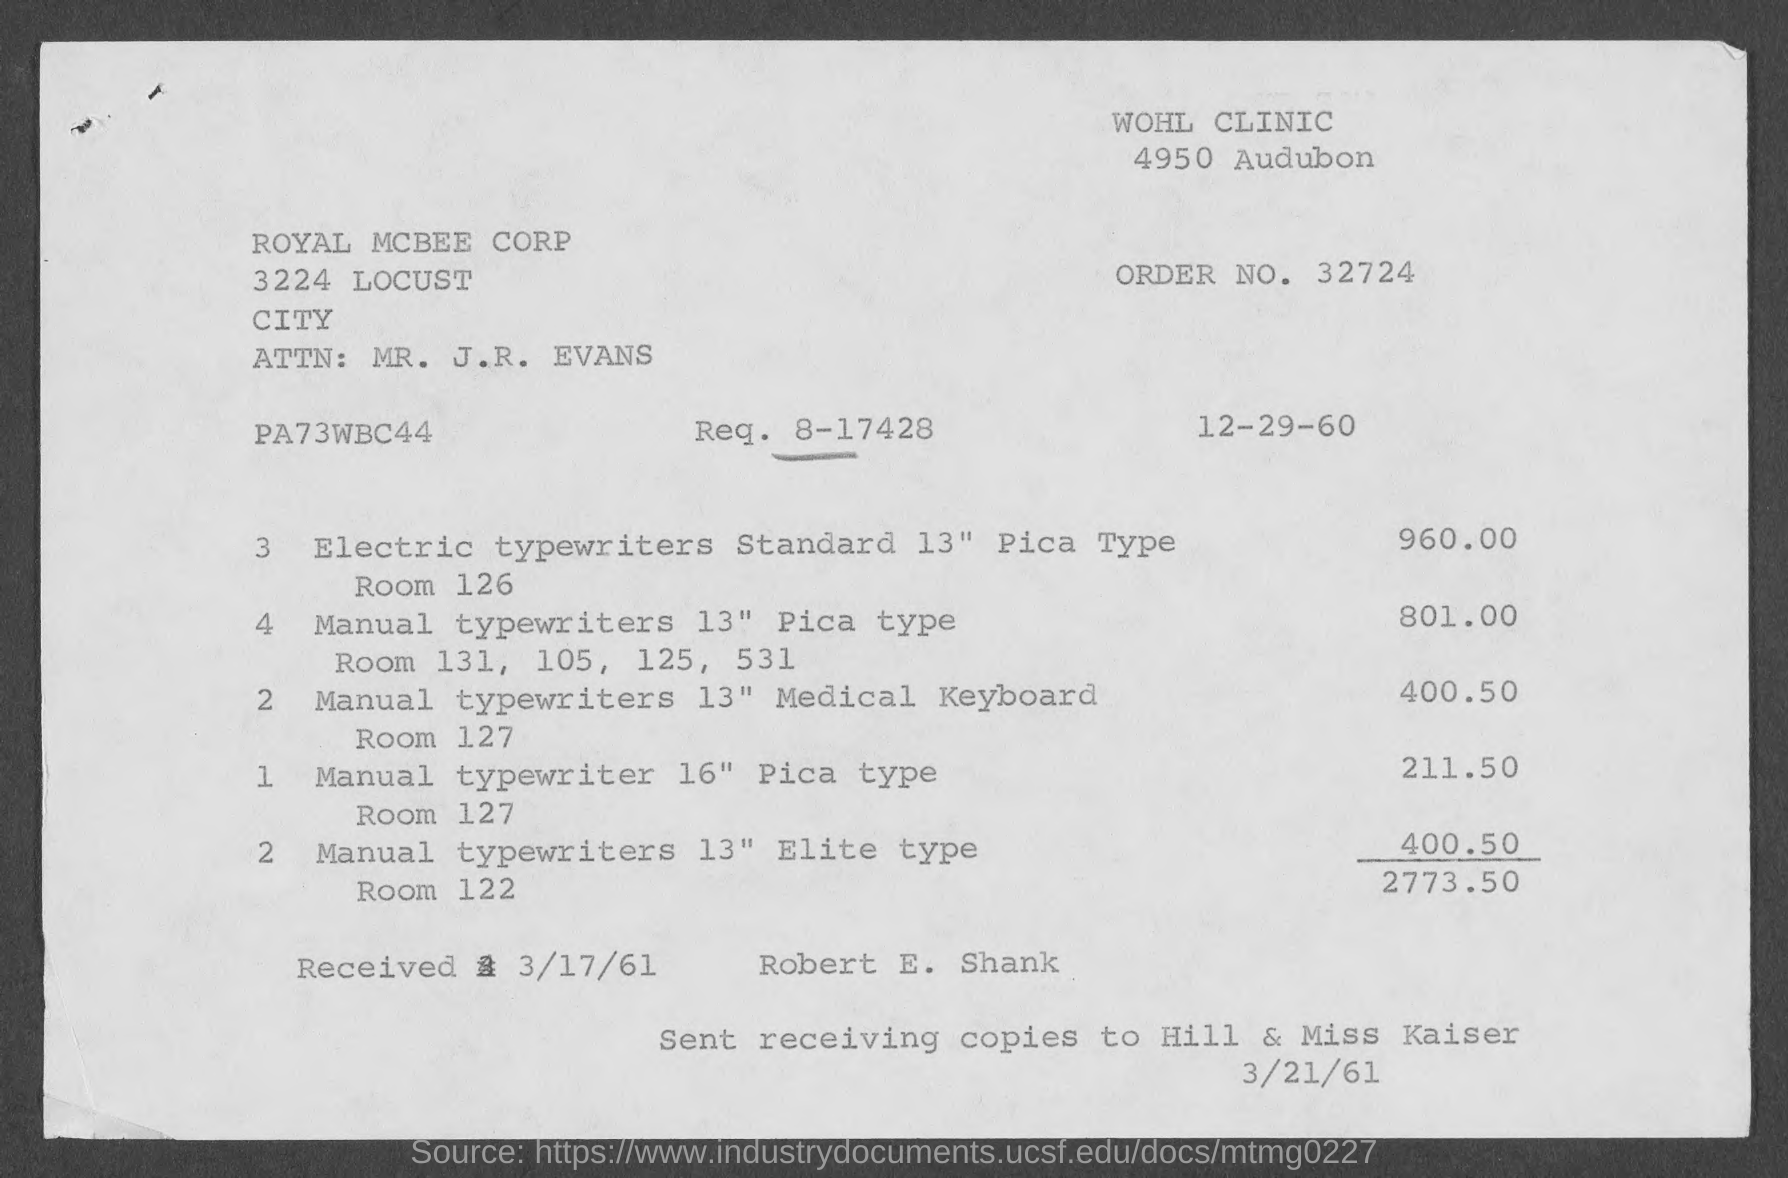Outline some significant characteristics in this image. The request number mentioned on the invoice is 8-17428. The issued date of the invoice is December 29, 1960. The received date mentioned in the invoice is 3/17/61. The total invoice amount, as per the document, is 2773.50.. The invoice is being raised by WOHL CLINIC. 